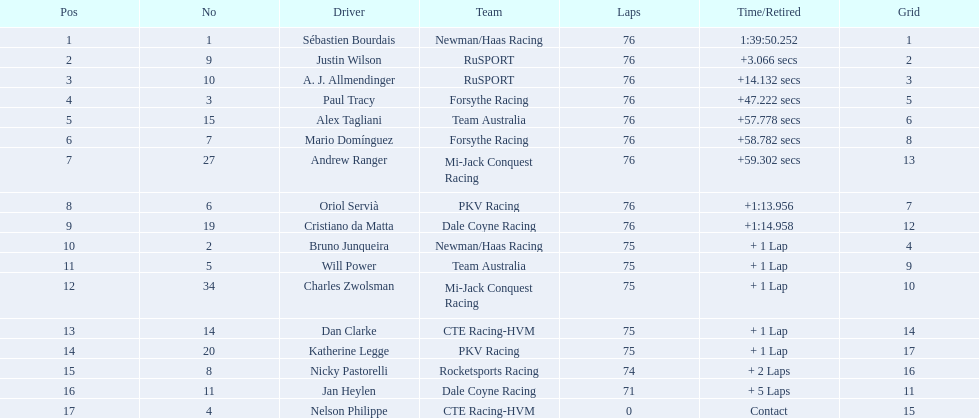What was alex taglini's final score in the tecate grand prix? 21. What was paul tracy's final score in the tecate grand prix? 23. Which driver finished first? Paul Tracy. 